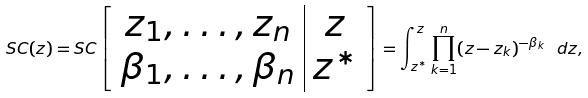Convert formula to latex. <formula><loc_0><loc_0><loc_500><loc_500>S C ( z ) = S C \left [ \begin{array} { c | c } z _ { 1 } , \dots , z _ { n } & z \\ \beta _ { 1 } , \dots , \beta _ { n } & z ^ { * } \end{array} \right ] = \int _ { z ^ { * } } ^ { z } \prod _ { k = 1 } ^ { n } ( z - z _ { k } ) ^ { - \beta _ { k } } \ d z ,</formula> 